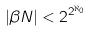Convert formula to latex. <formula><loc_0><loc_0><loc_500><loc_500>| \beta N | < 2 ^ { 2 ^ { \aleph _ { 0 } } }</formula> 